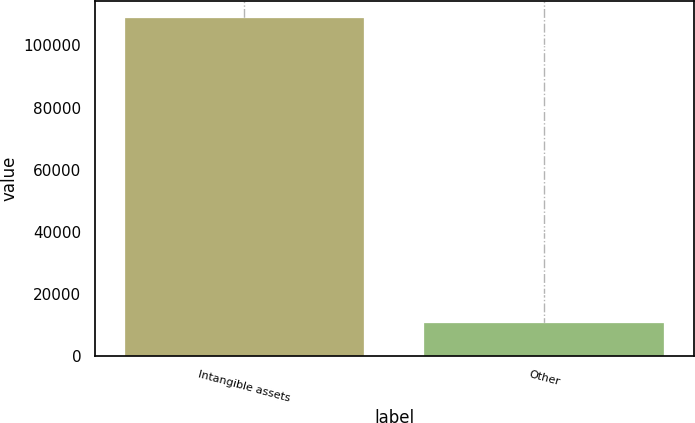Convert chart to OTSL. <chart><loc_0><loc_0><loc_500><loc_500><bar_chart><fcel>Intangible assets<fcel>Other<nl><fcel>108903<fcel>10575<nl></chart> 